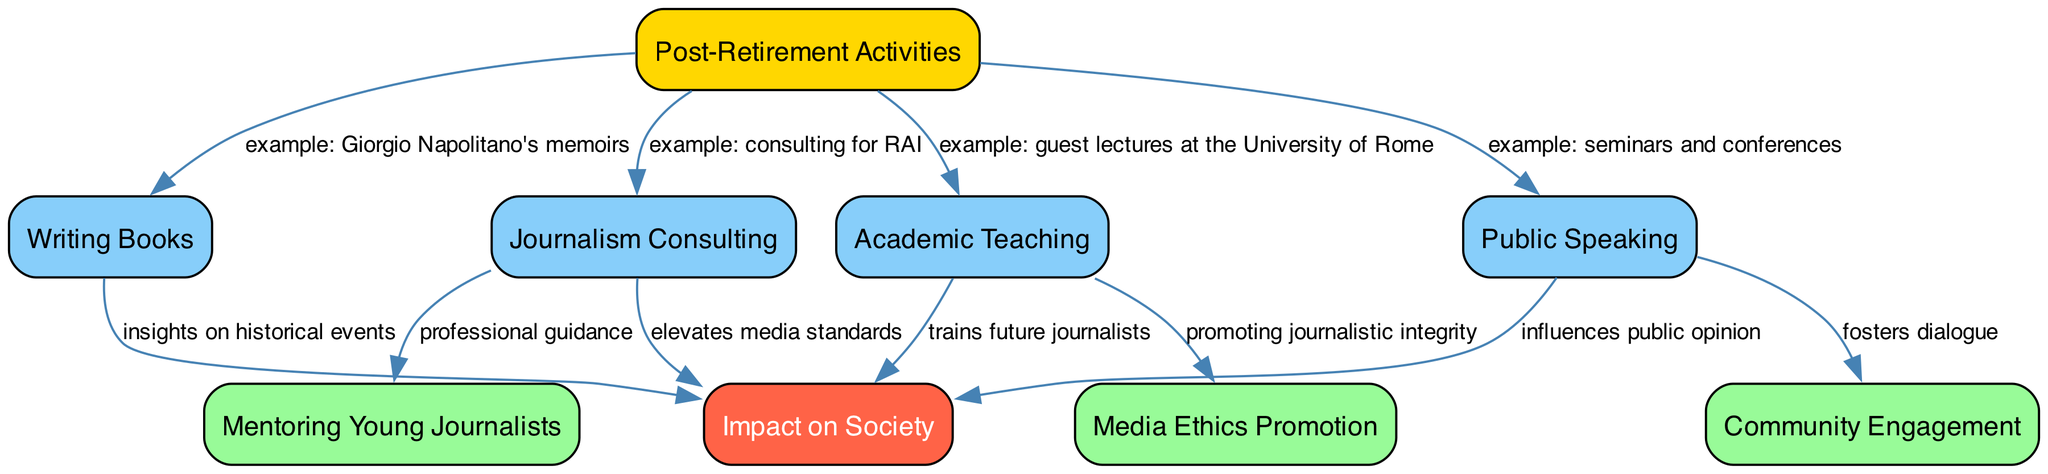What are the post-retirement activities listed in the diagram? The diagram lists various post-retirement activities including Writing Books, Journalism Consulting, Public Speaking, and Academic Teaching. These are represented as nodes directly connected to the main theme of Post-Retirement Activities.
Answer: Writing Books, Journalism Consulting, Public Speaking, Academic Teaching How many total nodes are present in the diagram? By counting all distinct entries in the nodes section of the data, we find there are a total of 9 nodes, each representing different activities or impacts associated with the post-retirement phase.
Answer: 9 What type of impact is associated with Writing Books? The relationship between Writing Books and Impact on Society is indicated as providing insights on historical events, showing how this activity contributes to societal knowledge and understanding.
Answer: insights on historical events What is the connection between Academic Teaching and Media Ethics? The diagram illustrates that Academic Teaching promotes media ethics, indicating that teaching activities directly influence the integrity of journalism practices in the society.
Answer: promoting journalistic integrity How does Public Speaking influence Community Engagement? Public Speaking fosters dialogue, as shown by the directed edge between these two nodes, indicating that engaging in public speaking can lead to greater interaction and communication within communities.
Answer: fosters dialogue Which activity helps in mentoring young journalists? Journalism Consulting has a direct link to mentoring young journalists, implying that experienced journalists who consult also provide guidance and support to those entering the field.
Answer: professional guidance What connects Public Speaking to Social Impact? The relationship between Public Speaking and Social Impact states that it influences public opinion, demonstrating how public speaking engagements can sway how society perceives various issues.
Answer: influences public opinion What is the primary role of Academic Teaching in relation to Social Impact? The diagram shows that Academic Teaching trains future journalists, demonstrating how educators in this field play a vital role in shaping the social landscape by preparing the next generation of media professionals.
Answer: trains future journalists What do the yellow and red nodes represent in the diagram? The yellow node represents Post-Retirement Activities, and the red node signifies Impact on Society. These colors indicate the main theme and its ultimate goal within the context of the diagram.
Answer: Post-Retirement Activities and Impact on Society 